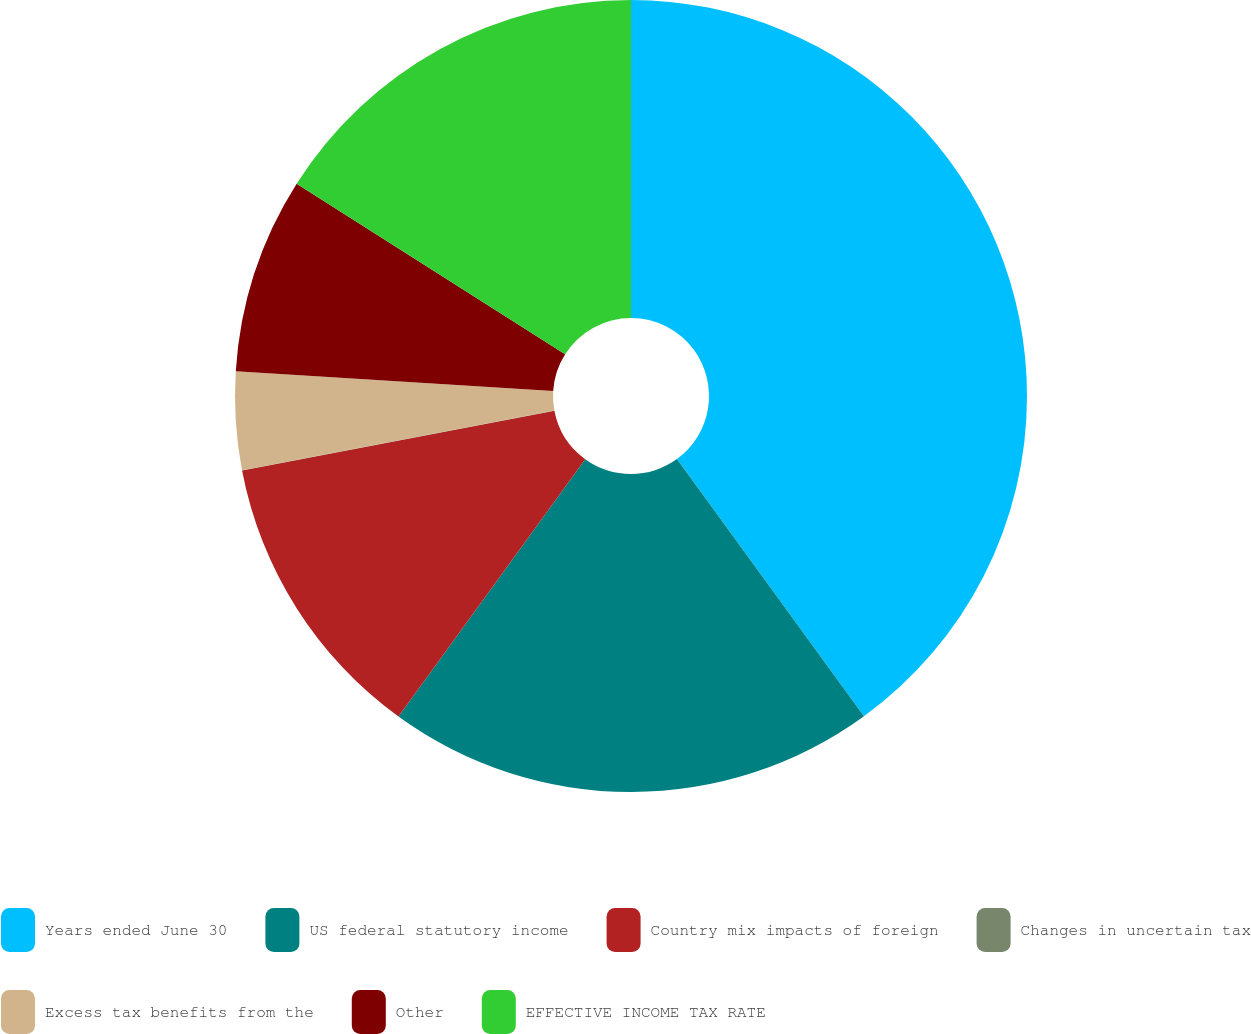Convert chart. <chart><loc_0><loc_0><loc_500><loc_500><pie_chart><fcel>Years ended June 30<fcel>US federal statutory income<fcel>Country mix impacts of foreign<fcel>Changes in uncertain tax<fcel>Excess tax benefits from the<fcel>Other<fcel>EFFECTIVE INCOME TAX RATE<nl><fcel>39.99%<fcel>20.0%<fcel>12.0%<fcel>0.01%<fcel>4.0%<fcel>8.0%<fcel>16.0%<nl></chart> 